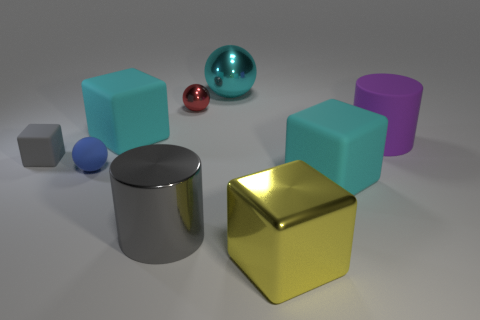Subtract all gray cubes. How many cubes are left? 3 Subtract all small metallic balls. How many balls are left? 2 Subtract all balls. How many objects are left? 6 Subtract 1 balls. How many balls are left? 2 Subtract all blue spheres. How many cyan cylinders are left? 0 Add 1 tiny blue matte spheres. How many tiny blue matte spheres are left? 2 Add 6 small blue spheres. How many small blue spheres exist? 7 Add 1 small blue balls. How many objects exist? 10 Subtract 0 green blocks. How many objects are left? 9 Subtract all brown spheres. Subtract all brown cylinders. How many spheres are left? 3 